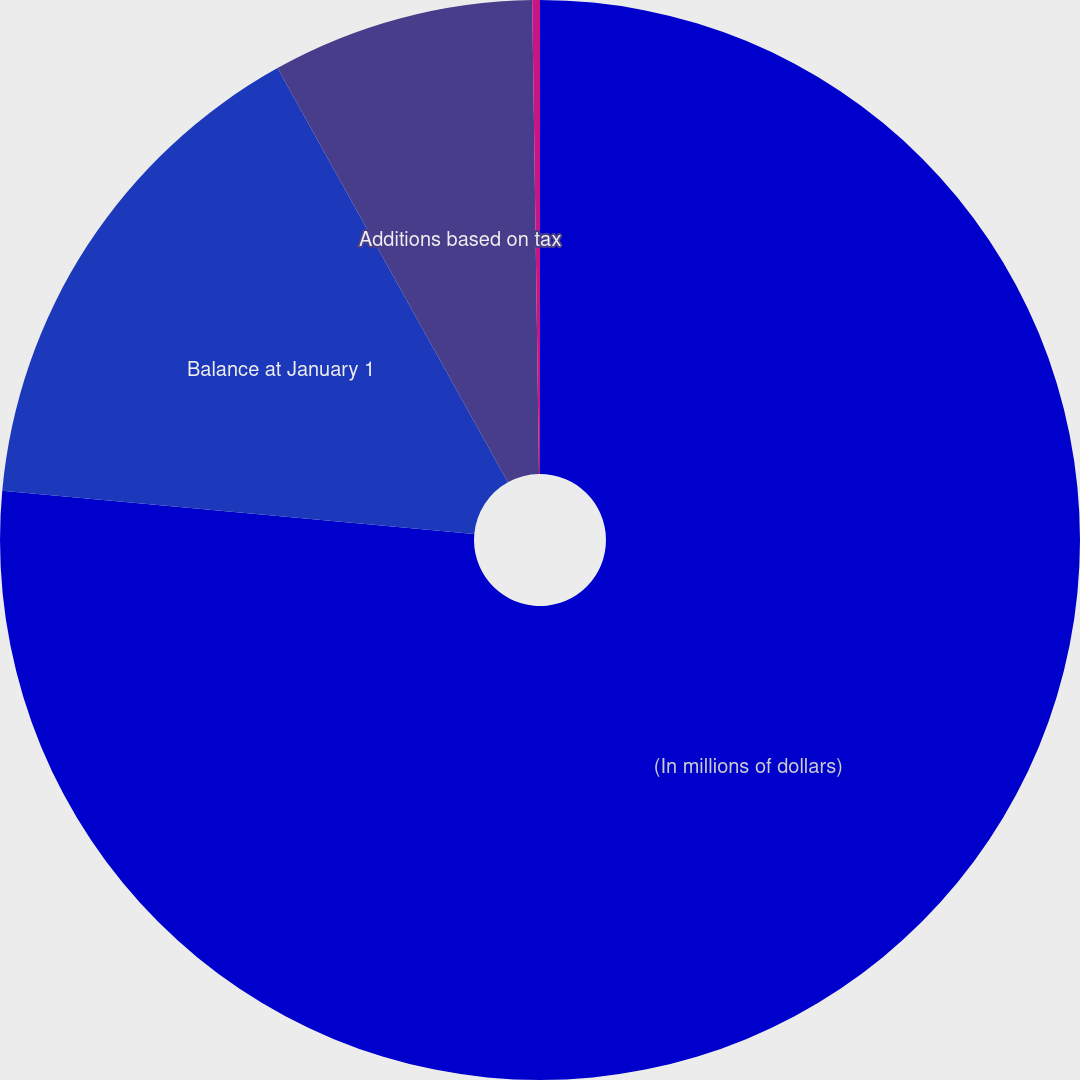Convert chart. <chart><loc_0><loc_0><loc_500><loc_500><pie_chart><fcel>(In millions of dollars)<fcel>Balance at January 1<fcel>Additions based on tax<fcel>Settlements<nl><fcel>76.45%<fcel>15.47%<fcel>7.85%<fcel>0.23%<nl></chart> 